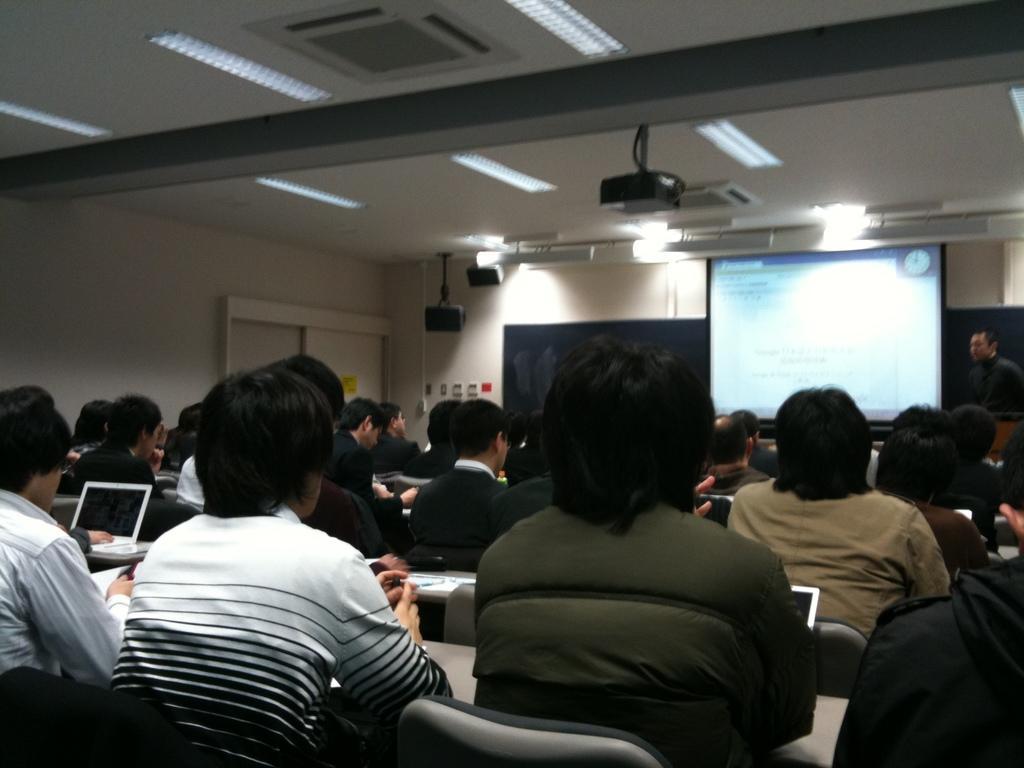Describe this image in one or two sentences. In this image I can see number of people are sitting on chairs. I can also see tables in the front of them and on it I can see few laptops. In the background I can see a projector screen and few black colour things. On the top side of this image I can see a projector machine and number of lights on the ceiling. I can also see a man is standing on the right side. 